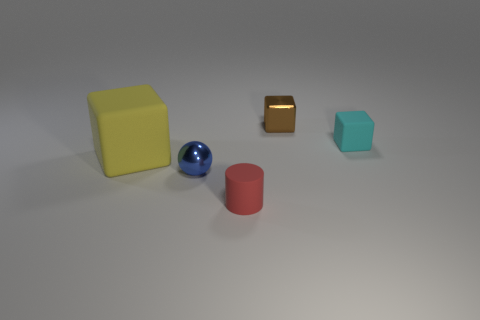Is the shape of the large object the same as the brown metallic object?
Ensure brevity in your answer.  Yes. What is the color of the object that is both right of the ball and in front of the tiny cyan rubber thing?
Keep it short and to the point. Red. There is a thing that is on the right side of the tiny shiny cube; is it the same size as the metal object that is in front of the small metallic cube?
Give a very brief answer. Yes. How many objects are metallic blocks that are behind the big cube or cyan matte things?
Your answer should be compact. 2. What is the tiny blue ball made of?
Keep it short and to the point. Metal. Does the yellow object have the same size as the blue shiny object?
Your response must be concise. No. How many cubes are tiny red objects or small cyan rubber things?
Give a very brief answer. 1. There is a tiny metal object left of the matte cylinder that is right of the big rubber object; what is its color?
Your answer should be compact. Blue. Is the number of small shiny objects right of the small brown cube less than the number of shiny things left of the small matte cylinder?
Keep it short and to the point. Yes. There is a cylinder; is it the same size as the cube left of the small brown metallic thing?
Provide a succinct answer. No. 